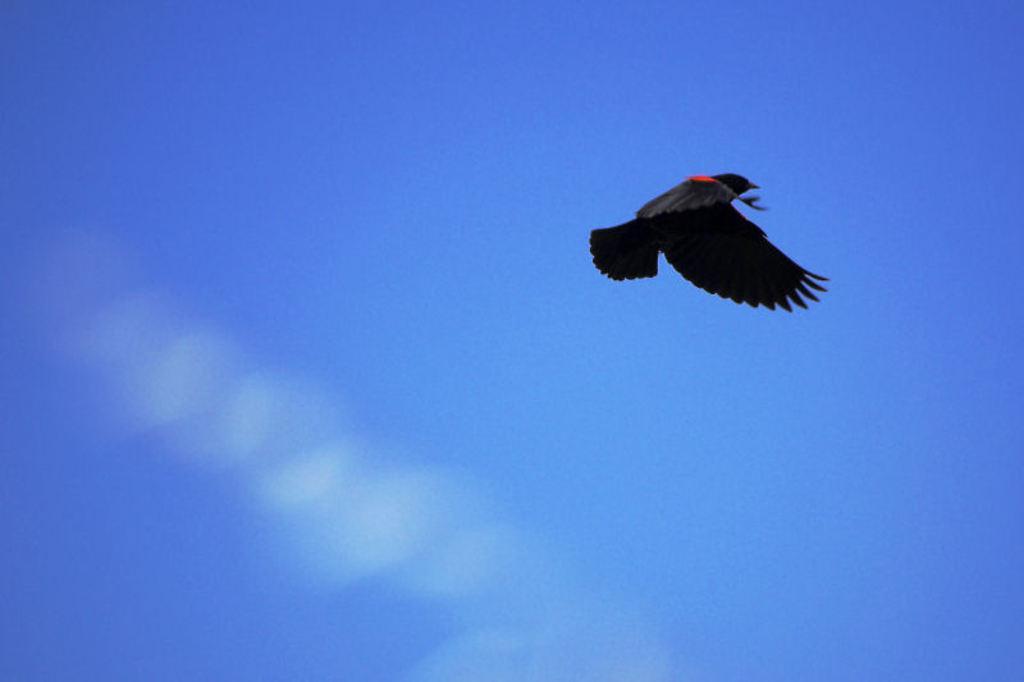Can you describe this image briefly? In this image I can see a bird flying in the sky. 